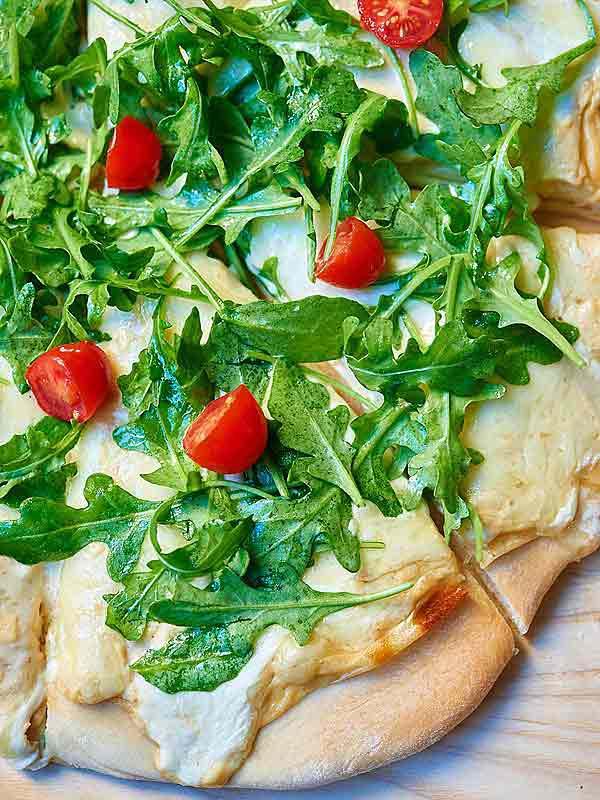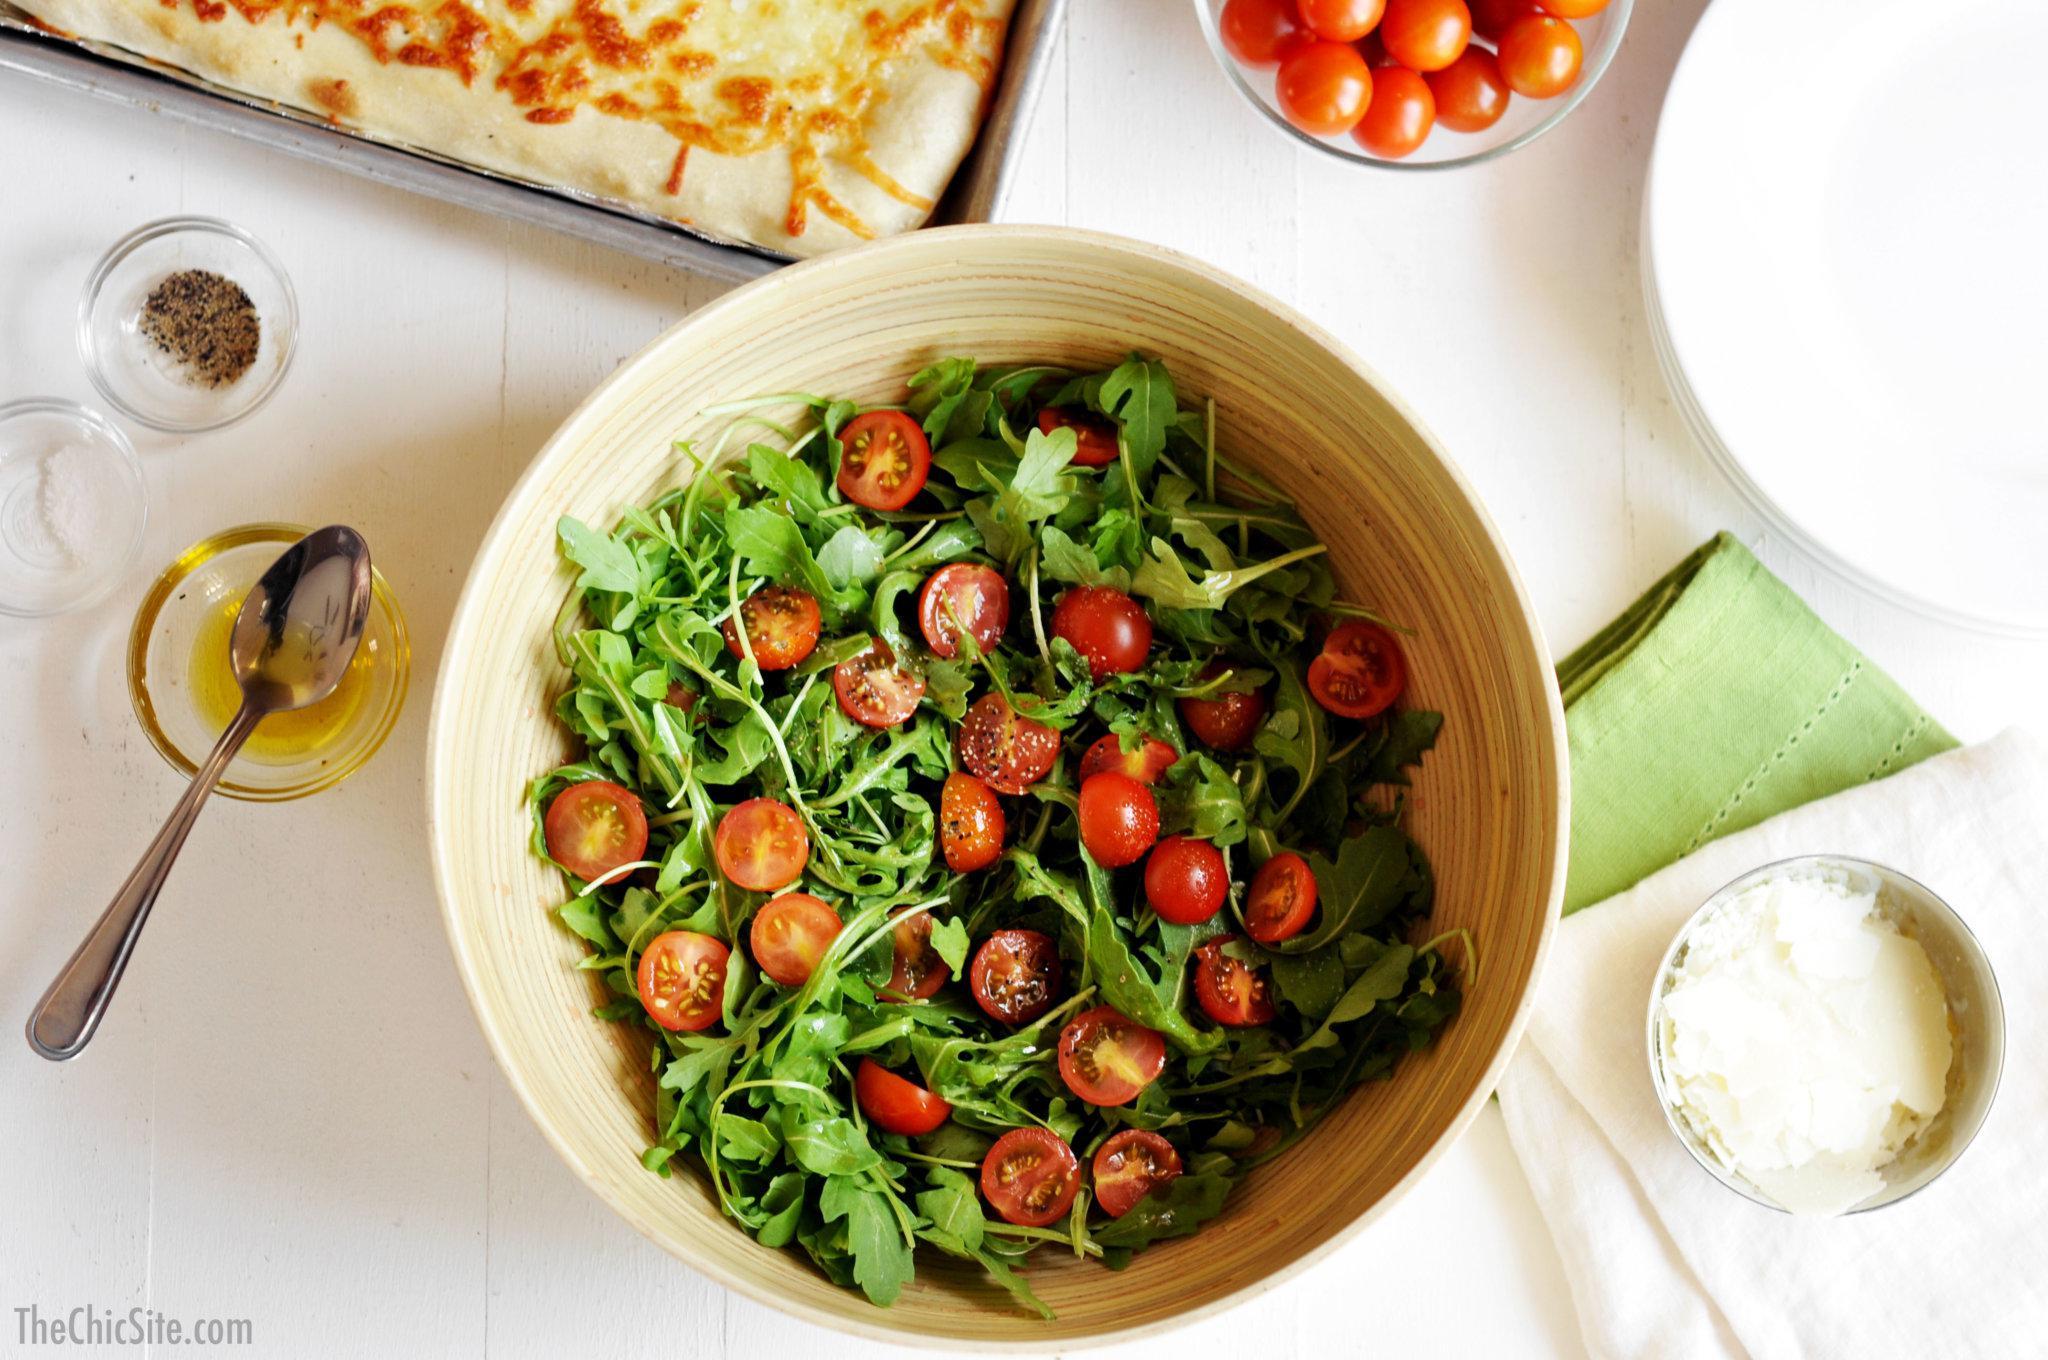The first image is the image on the left, the second image is the image on the right. Evaluate the accuracy of this statement regarding the images: "There are multiple pizzas in one of the images and only one pizza in the other image.". Is it true? Answer yes or no. No. The first image is the image on the left, the second image is the image on the right. For the images shown, is this caption "There are whole tomatoes." true? Answer yes or no. Yes. 